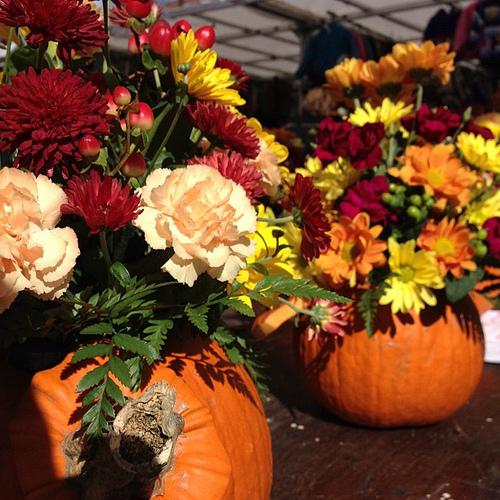Question: what is in the pumpkins?
Choices:
A. Candles.
B. Candy.
C. Flowers.
D. Leaves.
Answer with the letter. Answer: C Question: where are the flowers?
Choices:
A. In the basket.
B. In the vase.
C. In the glass.
D. In the pumpkins.
Answer with the letter. Answer: D Question: what color are the daisies?
Choices:
A. Yellow and orange.
B. Brown.
C. Red.
D. White.
Answer with the letter. Answer: A Question: how are the bouquets presented?
Choices:
A. In a vase.
B. In paper.
C. In plastic.
D. In pumpkins.
Answer with the letter. Answer: D Question: what is the table made out of?
Choices:
A. Glass.
B. Concrete.
C. Marble.
D. Wood.
Answer with the letter. Answer: D 